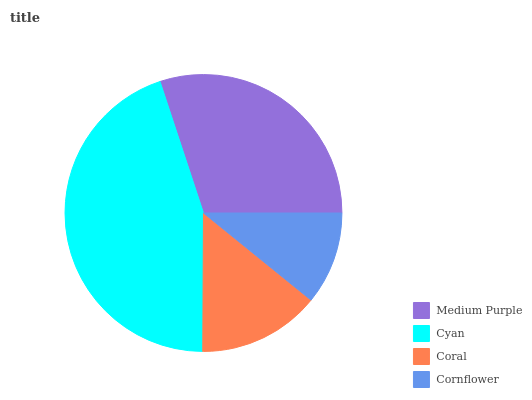Is Cornflower the minimum?
Answer yes or no. Yes. Is Cyan the maximum?
Answer yes or no. Yes. Is Coral the minimum?
Answer yes or no. No. Is Coral the maximum?
Answer yes or no. No. Is Cyan greater than Coral?
Answer yes or no. Yes. Is Coral less than Cyan?
Answer yes or no. Yes. Is Coral greater than Cyan?
Answer yes or no. No. Is Cyan less than Coral?
Answer yes or no. No. Is Medium Purple the high median?
Answer yes or no. Yes. Is Coral the low median?
Answer yes or no. Yes. Is Cyan the high median?
Answer yes or no. No. Is Medium Purple the low median?
Answer yes or no. No. 